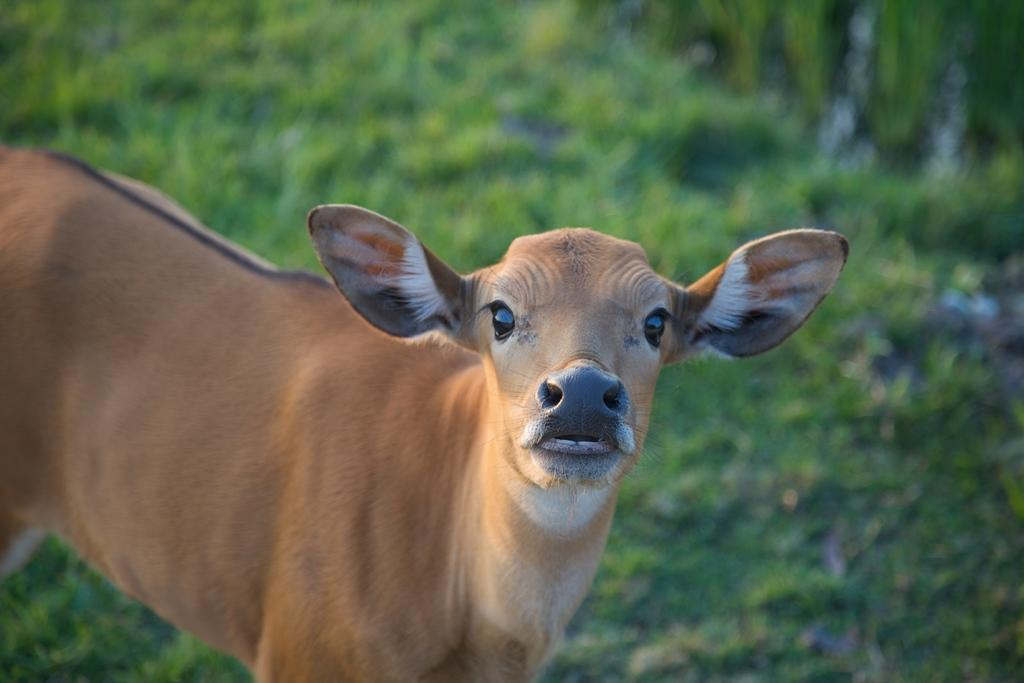What is the main subject in the center of the image? There is a cow in the center of the image. What type of vegetation can be seen in the background of the image? There is grass in the background of the image. What is the value of the downtown area in the image? There is no downtown area present in the image; it features a cow and grass. How does the cow maintain its grip on the ground in the image? The cow does not need to maintain a grip on the ground in the image; it is standing still on the grass. 